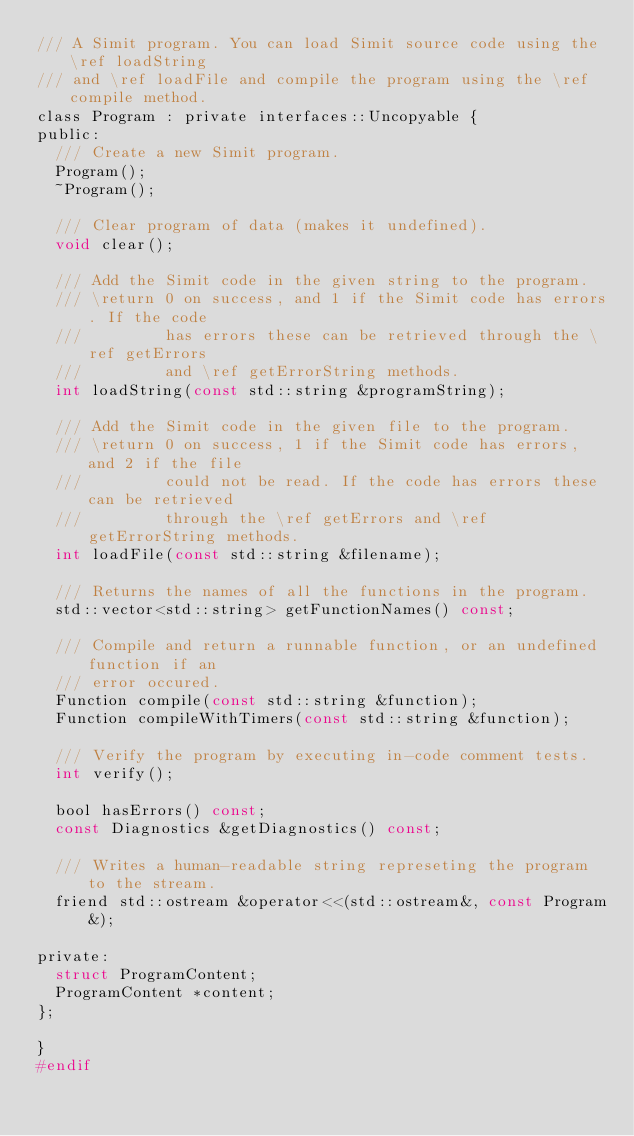<code> <loc_0><loc_0><loc_500><loc_500><_C_>/// A Simit program. You can load Simit source code using the \ref loadString
/// and \ref loadFile and compile the program using the \ref compile method.
class Program : private interfaces::Uncopyable {
public:
  /// Create a new Simit program.
  Program();
  ~Program();

  /// Clear program of data (makes it undefined).
  void clear();

  /// Add the Simit code in the given string to the program.
  /// \return 0 on success, and 1 if the Simit code has errors. If the code
  ///         has errors these can be retrieved through the \ref getErrors
  ///         and \ref getErrorString methods.
  int loadString(const std::string &programString);

  /// Add the Simit code in the given file to the program.
  /// \return 0 on success, 1 if the Simit code has errors, and 2 if the file
  ///         could not be read. If the code has errors these can be retrieved 
  ///         through the \ref getErrors and \ref getErrorString methods.
  int loadFile(const std::string &filename);

  /// Returns the names of all the functions in the program.
  std::vector<std::string> getFunctionNames() const;

  /// Compile and return a runnable function, or an undefined function if an
  /// error occured.
  Function compile(const std::string &function);
  Function compileWithTimers(const std::string &function);

  /// Verify the program by executing in-code comment tests.
  int verify();

  bool hasErrors() const;
  const Diagnostics &getDiagnostics() const;

  /// Writes a human-readable string represeting the program to the stream.
  friend std::ostream &operator<<(std::ostream&, const Program&);

private:
  struct ProgramContent;
  ProgramContent *content;
};

}
#endif
</code> 